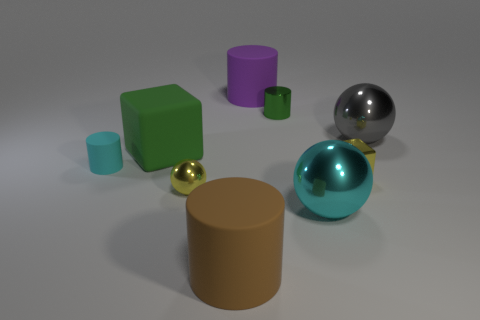Subtract all cylinders. How many objects are left? 5 Subtract 0 gray cylinders. How many objects are left? 9 Subtract all large cylinders. Subtract all tiny cyan rubber things. How many objects are left? 6 Add 6 green rubber things. How many green rubber things are left? 7 Add 4 gray balls. How many gray balls exist? 5 